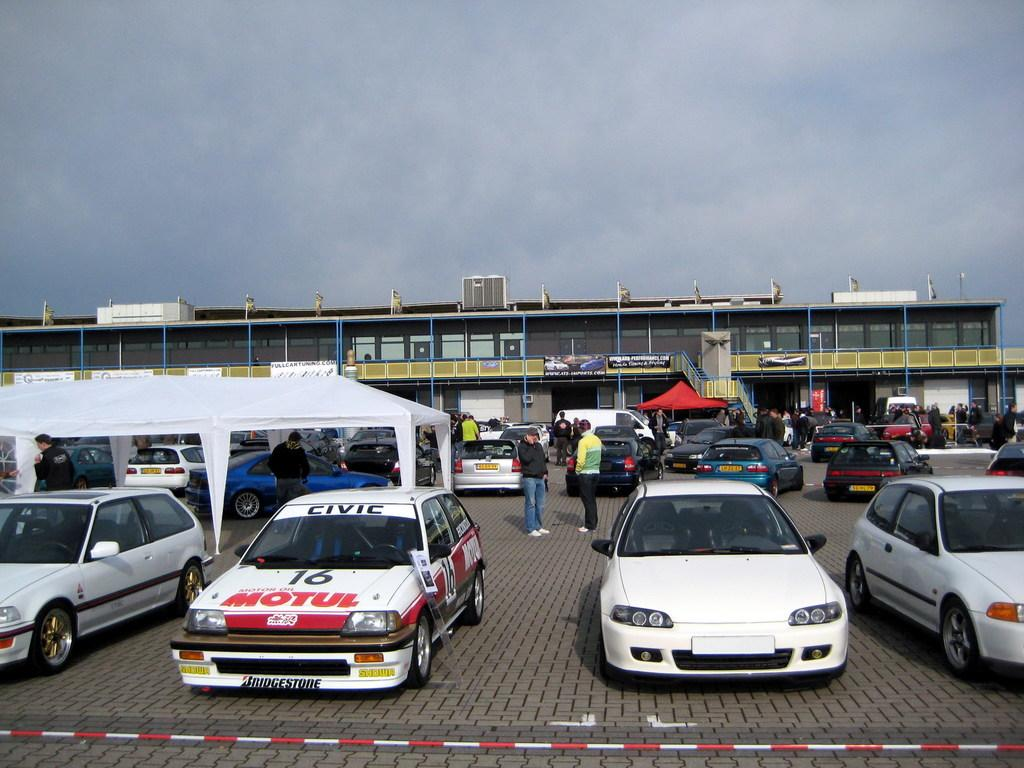What can be seen in the front of the image? There are cars parked in the front of the image. What type of building is visible in the image? There is a glass car showroom in the image. What colors are the canopy sheds of the car showroom? The car showroom has red and white color canopy sheds. Can you tell me how many boats are parked in the car showroom? There are no boats present in the image; it features a glass car showroom with cars parked outside. What type of terrain is the car showroom built on, such as quicksand? The image does not provide information about the terrain or any specific ground conditions, such as quicksand. 